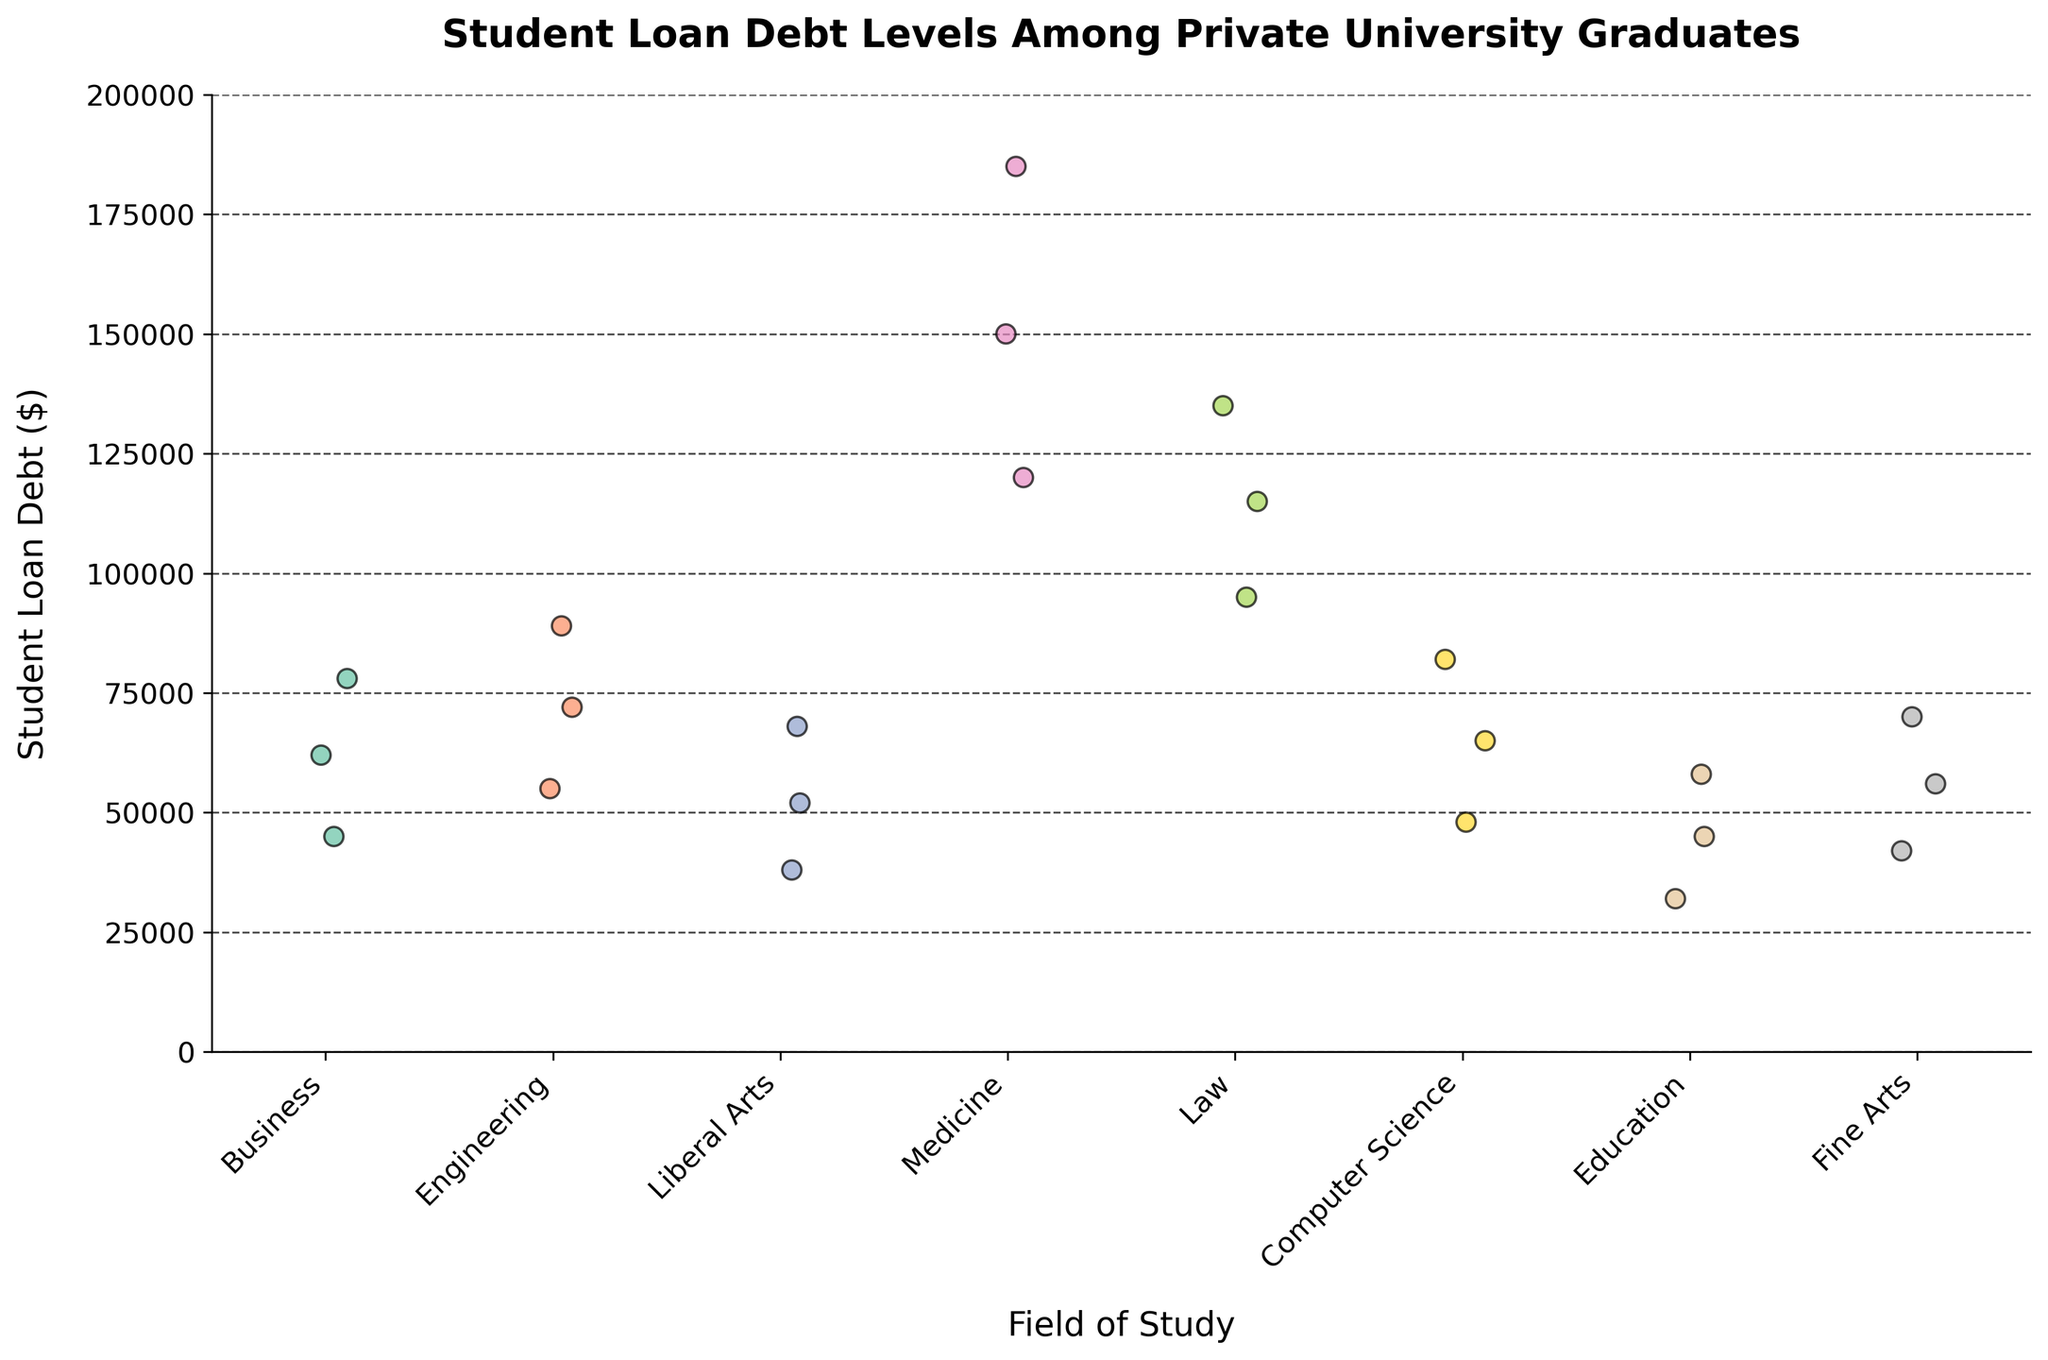What is the title of the figure? The title of the figure is written at the top and generally explains what the figure is about.
Answer: Student Loan Debt Levels Among Private University Graduates Which field of study has the highest student loan debt recorded? By looking at the highest point on the y-axis for each field of study, we can identify the field with the highest student loan debt. The highest point is for Medicine.
Answer: Medicine How many fields of study are included in the plot? Count the number of unique labels on the x-axis, which represent different fields of study.
Answer: 8 Which field of study has the least variation in student loan debt levels? By observing how spread out the data points are for each field of study along the y-axis, the field with the least spread (least variation) would be identified.
Answer: Education What is the average student loan debt for Computer Science graduates? Sum the student loan debts for Computer Science graduates and divide by the total number of data points for Computer Science. The debts are 48000, 65000, and 82000. (48000 + 65000 + 82000)/3 = 65000
Answer: 65000 Compare the maximum student loan debts between Law and Engineering. Identify the highest data point for each of these fields and compare them. Law has 135000 and Engineering has 89000. So, Law has a higher maximum student loan debt.
Answer: Law Which field has the data points most closely clustered around the same debt level? Look for the field where data points are most concentrated near a particular value on the y-axis. This is typically where points show less spread from a single line.
Answer: Fine Arts What is the difference between the highest student loan debt in Business and the highest in Medicine? Identify the highest data point in Business (78000) and in Medicine (185000), then subtract the two values. 185000 - 78000 = 107000
Answer: 107000 Which field has a median student loan debt level between 40000 and 60000? The median is the middle value when the data points are ordered. For Education, the data points are 32000, 45000, and 58000. The middle value, and hence the median, is 45000, which is within the range 40000-60000.
Answer: Education 